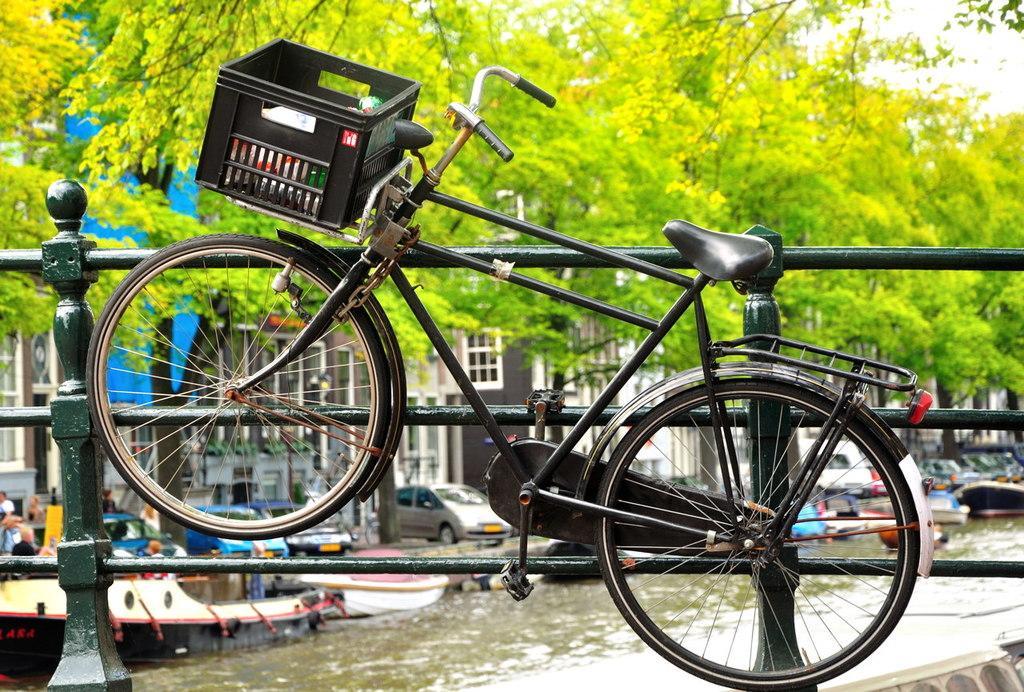In one or two sentences, can you explain what this image depicts? In this picture there is bicycle in the foreground and there is a basket on the bicycle, behind the bicycle there is a railing. At the back there are buildings and trees and there are boats on the water and there are vehicles on the road and there are group of people on the road. At the top there is sky. At the bottom there is water. 